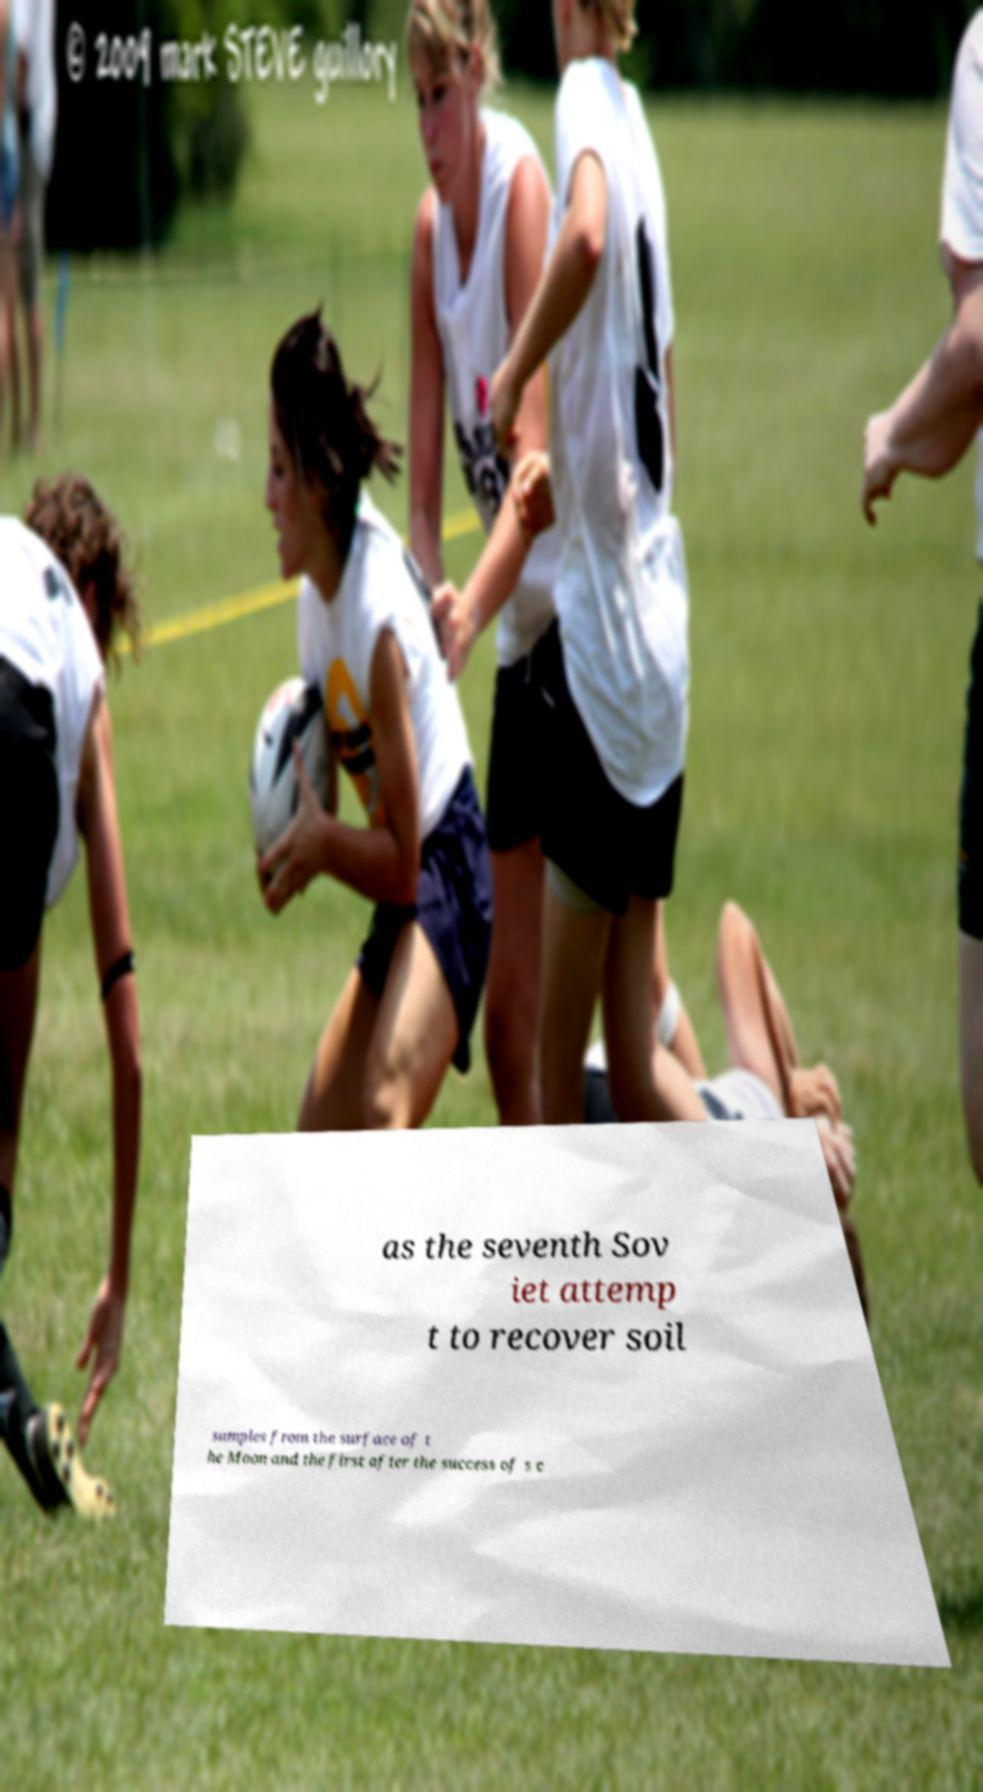Could you assist in decoding the text presented in this image and type it out clearly? as the seventh Sov iet attemp t to recover soil samples from the surface of t he Moon and the first after the success of s c 